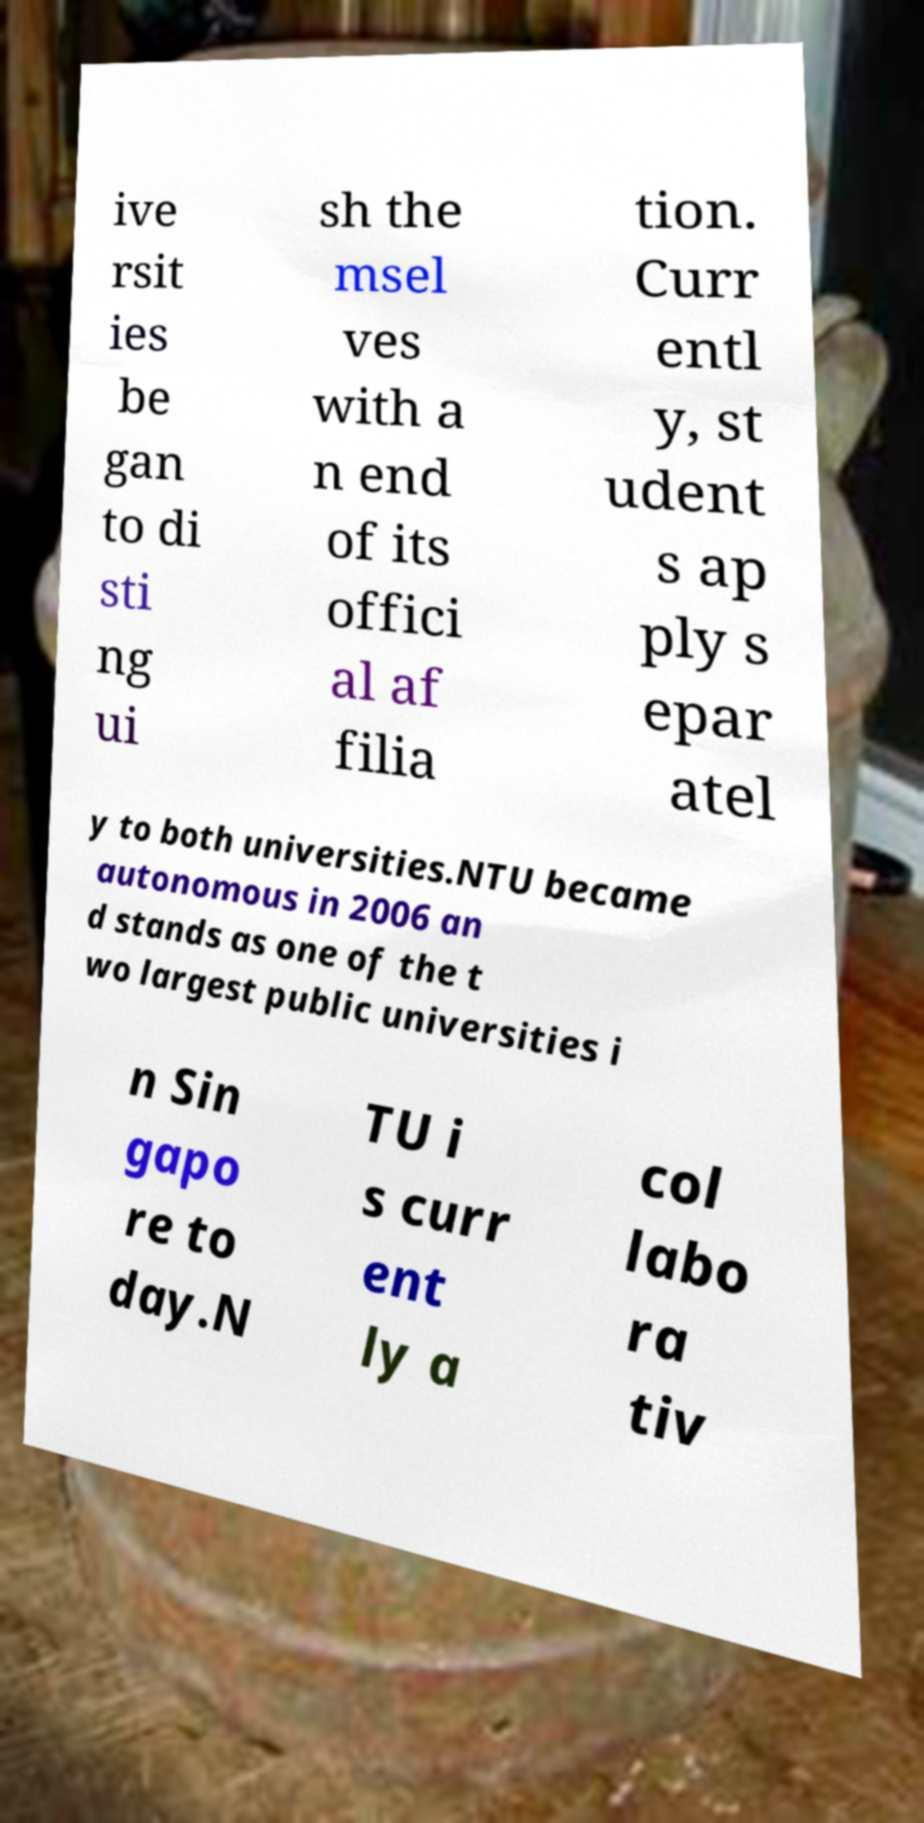Could you assist in decoding the text presented in this image and type it out clearly? ive rsit ies be gan to di sti ng ui sh the msel ves with a n end of its offici al af filia tion. Curr entl y, st udent s ap ply s epar atel y to both universities.NTU became autonomous in 2006 an d stands as one of the t wo largest public universities i n Sin gapo re to day.N TU i s curr ent ly a col labo ra tiv 